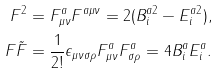Convert formula to latex. <formula><loc_0><loc_0><loc_500><loc_500>F ^ { 2 } = F ^ { a } _ { \mu \nu } F ^ { a \mu \nu } = 2 ( B ^ { a 2 } _ { i } - E ^ { a 2 } _ { i } ) , \\ F \tilde { F } = \frac { 1 } { 2 ! } \epsilon _ { \mu \nu \sigma \rho } F ^ { a } _ { \mu \nu } F ^ { a } _ { \sigma \rho } = 4 B ^ { a } _ { i } E ^ { a } _ { i } .</formula> 